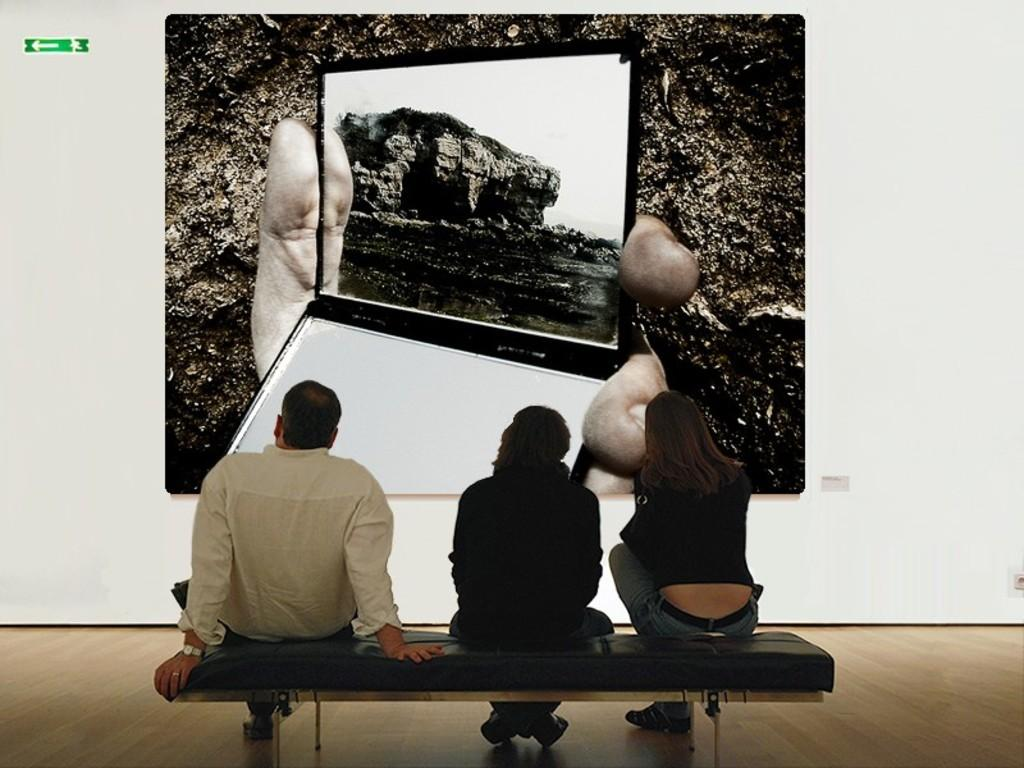How many people are in the image? There are three people in the foreground of the image. What are the people doing in the image? The people are sitting on a bench-like object on the wooden floor. What can be seen on the wall in the background of the image? There is a frame on the wall in the background of the image. Can you see any deer swimming in the image? There are no deer or swimming activities present in the image. 